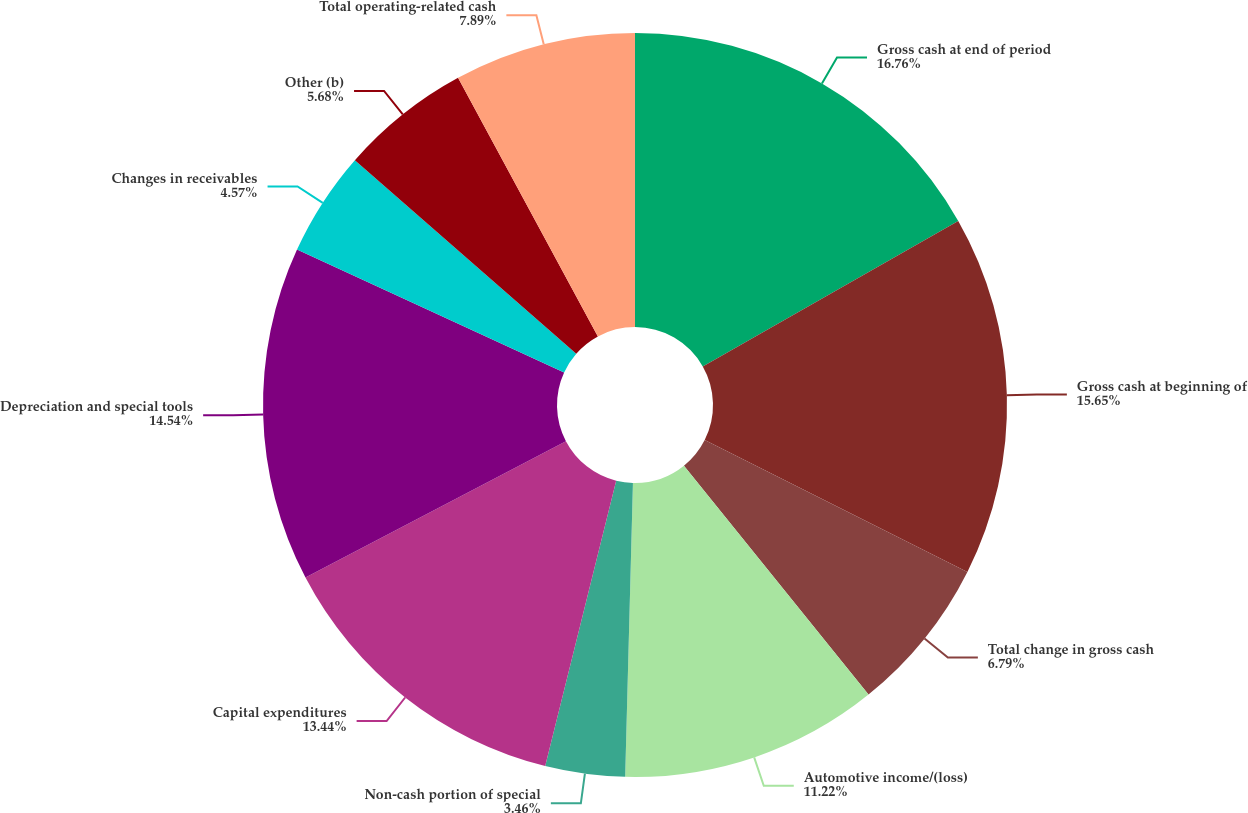Convert chart to OTSL. <chart><loc_0><loc_0><loc_500><loc_500><pie_chart><fcel>Gross cash at end of period<fcel>Gross cash at beginning of<fcel>Total change in gross cash<fcel>Automotive income/(loss)<fcel>Non-cash portion of special<fcel>Capital expenditures<fcel>Depreciation and special tools<fcel>Changes in receivables<fcel>Other (b)<fcel>Total operating-related cash<nl><fcel>16.76%<fcel>15.65%<fcel>6.79%<fcel>11.22%<fcel>3.46%<fcel>13.44%<fcel>14.54%<fcel>4.57%<fcel>5.68%<fcel>7.89%<nl></chart> 